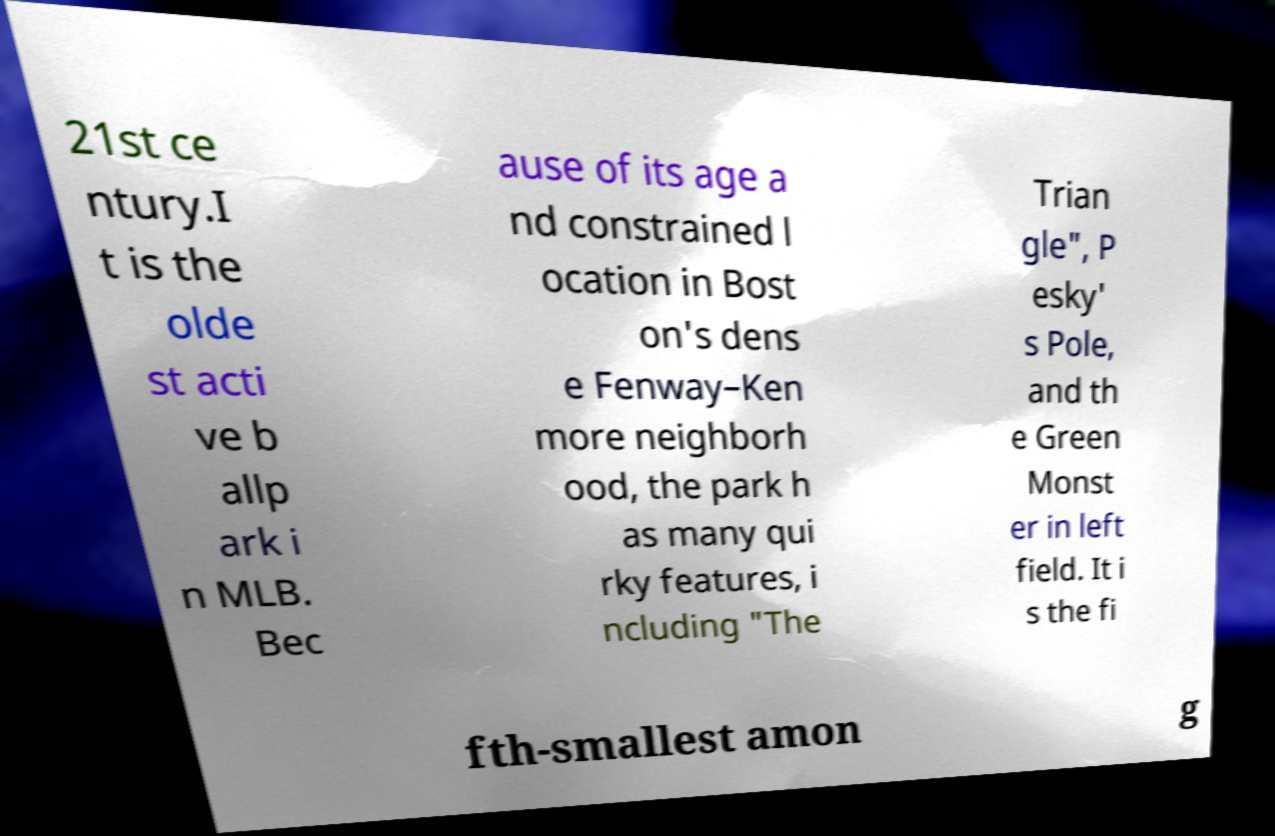For documentation purposes, I need the text within this image transcribed. Could you provide that? 21st ce ntury.I t is the olde st acti ve b allp ark i n MLB. Bec ause of its age a nd constrained l ocation in Bost on's dens e Fenway–Ken more neighborh ood, the park h as many qui rky features, i ncluding "The Trian gle", P esky' s Pole, and th e Green Monst er in left field. It i s the fi fth-smallest amon g 